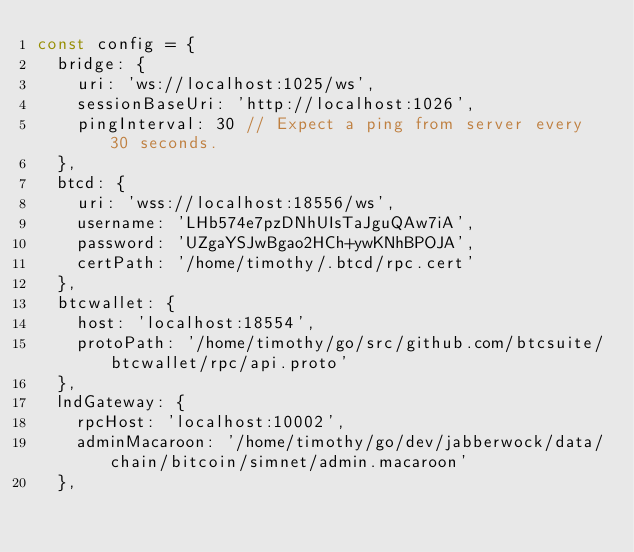<code> <loc_0><loc_0><loc_500><loc_500><_JavaScript_>const config = {
  bridge: {
    uri: 'ws://localhost:1025/ws',
    sessionBaseUri: 'http://localhost:1026',
    pingInterval: 30 // Expect a ping from server every 30 seconds.
  },
  btcd: {
    uri: 'wss://localhost:18556/ws',
    username: 'LHb574e7pzDNhUIsTaJguQAw7iA',
    password: 'UZgaYSJwBgao2HCh+ywKNhBPOJA',
    certPath: '/home/timothy/.btcd/rpc.cert'
  },
  btcwallet: {
    host: 'localhost:18554',
    protoPath: '/home/timothy/go/src/github.com/btcsuite/btcwallet/rpc/api.proto'
  },
  lndGateway: {
    rpcHost: 'localhost:10002',
    adminMacaroon: '/home/timothy/go/dev/jabberwock/data/chain/bitcoin/simnet/admin.macaroon'
  },</code> 